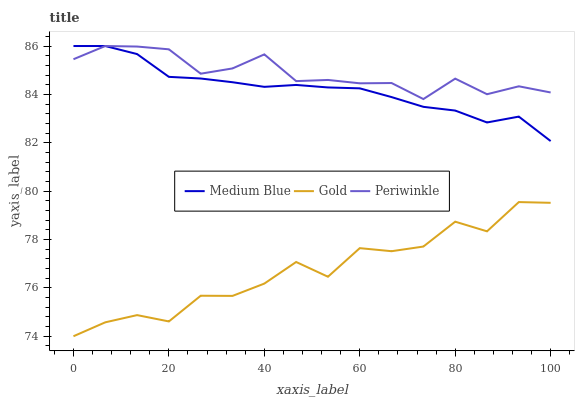Does Gold have the minimum area under the curve?
Answer yes or no. Yes. Does Periwinkle have the maximum area under the curve?
Answer yes or no. Yes. Does Medium Blue have the minimum area under the curve?
Answer yes or no. No. Does Medium Blue have the maximum area under the curve?
Answer yes or no. No. Is Medium Blue the smoothest?
Answer yes or no. Yes. Is Gold the roughest?
Answer yes or no. Yes. Is Gold the smoothest?
Answer yes or no. No. Is Medium Blue the roughest?
Answer yes or no. No. Does Gold have the lowest value?
Answer yes or no. Yes. Does Medium Blue have the lowest value?
Answer yes or no. No. Does Medium Blue have the highest value?
Answer yes or no. Yes. Does Gold have the highest value?
Answer yes or no. No. Is Gold less than Medium Blue?
Answer yes or no. Yes. Is Periwinkle greater than Gold?
Answer yes or no. Yes. Does Periwinkle intersect Medium Blue?
Answer yes or no. Yes. Is Periwinkle less than Medium Blue?
Answer yes or no. No. Is Periwinkle greater than Medium Blue?
Answer yes or no. No. Does Gold intersect Medium Blue?
Answer yes or no. No. 